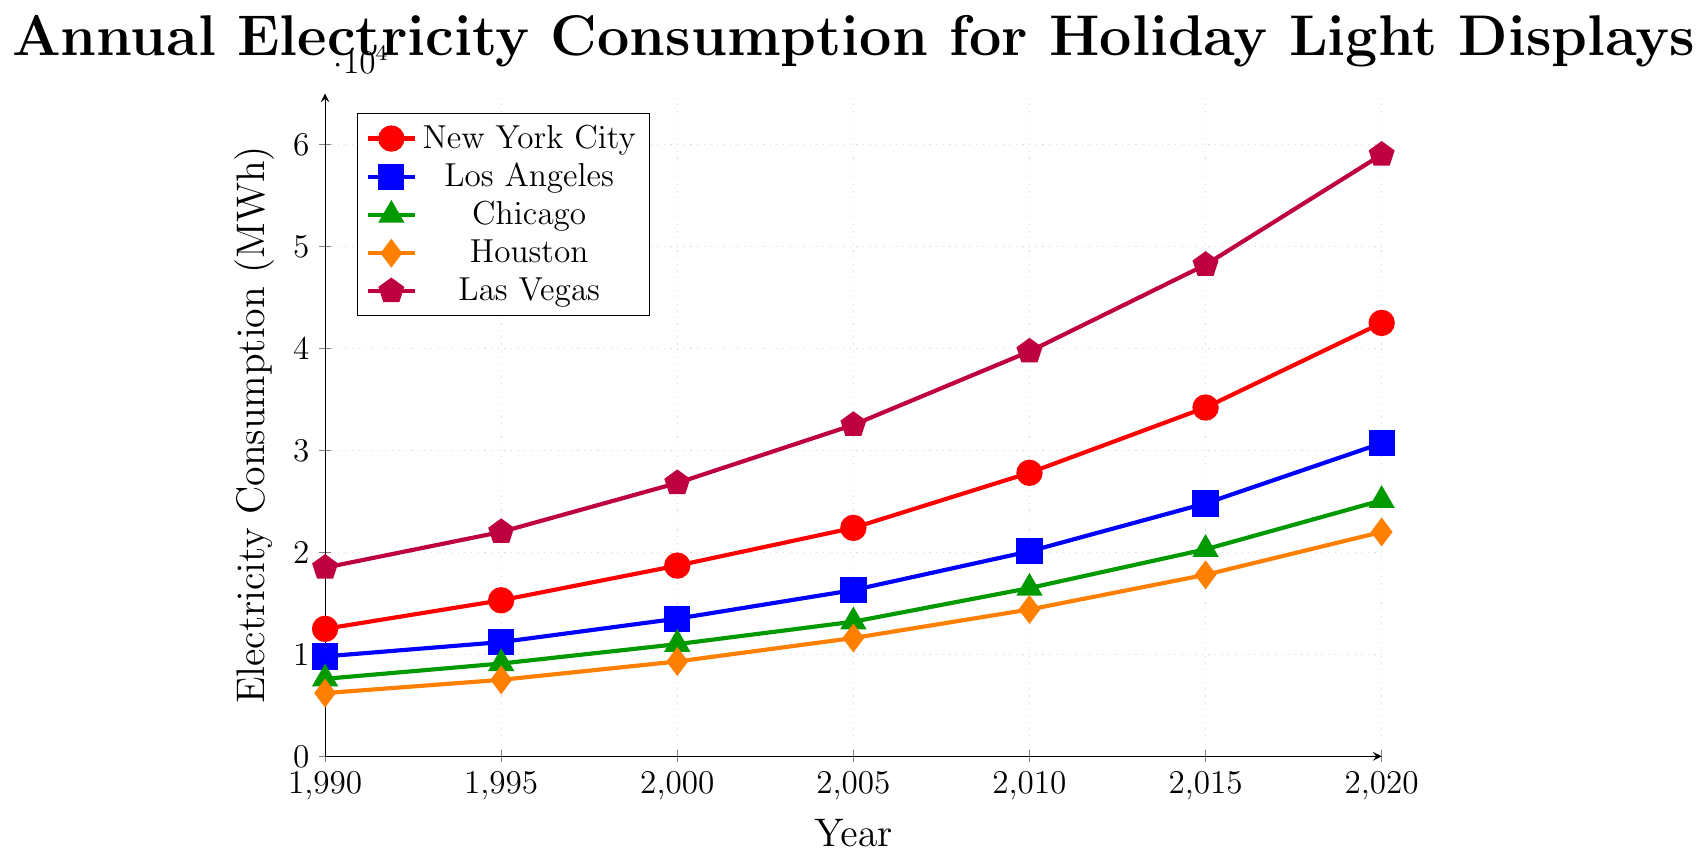What's the trend for electricity consumption in New York City from 1990 to 2020? To determine the trend, observe the values for New York City at each time point. Starting at 12,500 MWh in 1990 and increasing steadily to 42,500 MWh in 2020 shows a consistent upward trend in electricity consumption.
Answer: Increasing Which city had the highest electricity consumption in 2020, and what was the value? By looking at the data points for the year 2020, Las Vegas has the highest consumption at 59,000 MWh.
Answer: Las Vegas, 59,000 In which year did Los Angeles surpass 20,000 MWh in electricity consumption? Checking the values for Los Angeles, it surpassed 20,000 MWh in 2010 when it reached 20,100 MWh.
Answer: 2010 Comparing Houston’s and Chicago's electricity consumption in 2005, which city used more and by how much? Houston's consumption in 2005 was 11,600 MWh, while Chicago's was 13,200 MWh. Chicago used more, and the difference is 1,600 MWh.
Answer: Chicago, 1,600 Which city showed the greatest increase in electricity consumption between 1990 and 2020? Calculate the difference for each city: 
- New York City: 42,500 - 12,500 = 30,000 MWh
- Los Angeles: 30,700 - 9,800 = 20,900 MWh
- Chicago: 25,100 - 7,600 = 17,500 MWh
- Houston: 22,000 - 6,200 = 15,800 MWh
- Las Vegas: 59,000 - 18,500 = 40,500 MWh
Las Vegas had the greatest increase of 40,500 MWh.
Answer: Las Vegas, 40,500 What’s the average electricity consumption for Chicago over the observed years? The values for Chicago are 7,600, 9,100, 11,000, 13,200, 16,500, 20,300, and 25,100. Sum these values to get 102,800 MWh, then divide by the number of data points (7) to find the average: 102,800 / 7 ≈ 14,686 MWh.
Answer: 14,686 How much more electricity did Las Vegas consume in 2015 compared to New York City in the same year? In 2015, Las Vegas consumed 48,200 MWh, and New York City consumed 34,200 MWh. The difference is 48,200 - 34,200 = 14,000 MWh.
Answer: 14,000 Between which consecutive years did New York City see its highest increase in electricity consumption? Calculating each interval:
- 1990-1995: 15,300 - 12,500 = 2,800 MWh
- 1995-2000: 18,700 - 15,300 = 3,400 MWh
- 2000-2005: 22,400 - 18,700 = 3,700 MWh
- 2005-2010: 27,800 - 22,400 = 5,400 MWh
- 2010-2015: 34,200 - 27,800 = 6,400 MWh
- 2015-2020: 42,500 - 34,200 = 8,300 MWh
The highest increase occurred between 2015 and 2020 with an increase of 8,300 MWh.
Answer: 2015-2020, 8,300 What is the total electricity consumption across all cities in 1995? Sum the consumption values for 1995: New York City (15,300), Los Angeles (11,200), Chicago (9,100), Houston (7,500), Las Vegas (22,000). Total = 15,300 + 11,200 + 9,100 + 7,500 + 22,000 = 65,100 MWh.
Answer: 65,100 Which city had the smallest growth in electricity consumption from 1990 to 2020? Calculate the increase for each city as in the earlier question. Chicago had the smallest growth: 25,100 - 7,600 = 17,500 MWh.
Answer: Chicago, 17,500 